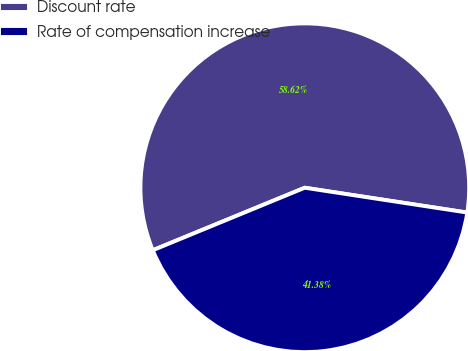Convert chart. <chart><loc_0><loc_0><loc_500><loc_500><pie_chart><fcel>Discount rate<fcel>Rate of compensation increase<nl><fcel>58.62%<fcel>41.38%<nl></chart> 